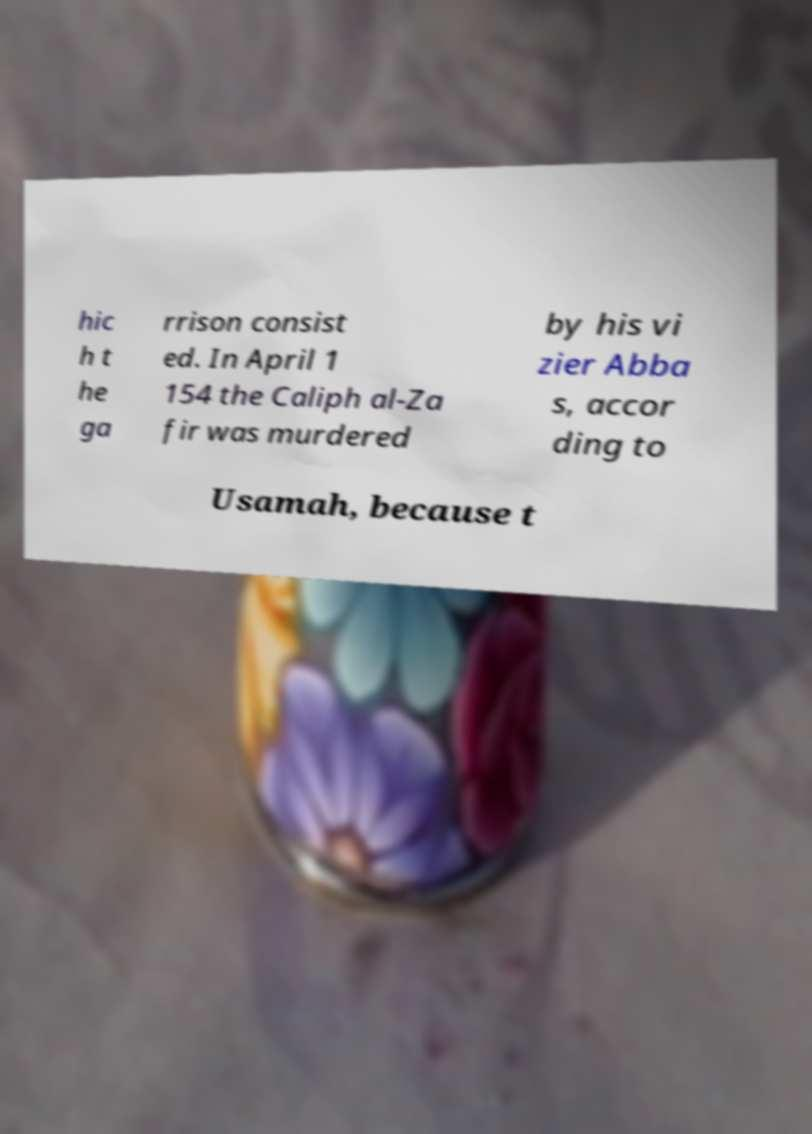I need the written content from this picture converted into text. Can you do that? hic h t he ga rrison consist ed. In April 1 154 the Caliph al-Za fir was murdered by his vi zier Abba s, accor ding to Usamah, because t 